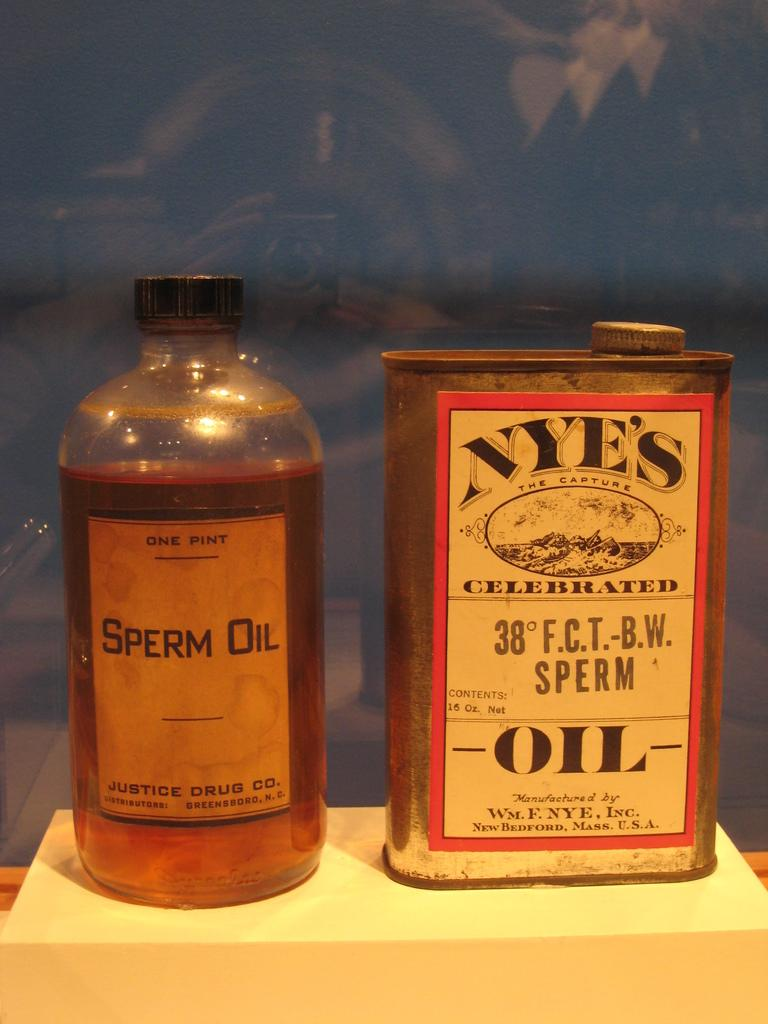<image>
Describe the image concisely. Sperm Oil by the Justice Drug Company sitting next to another bottle of oil. 